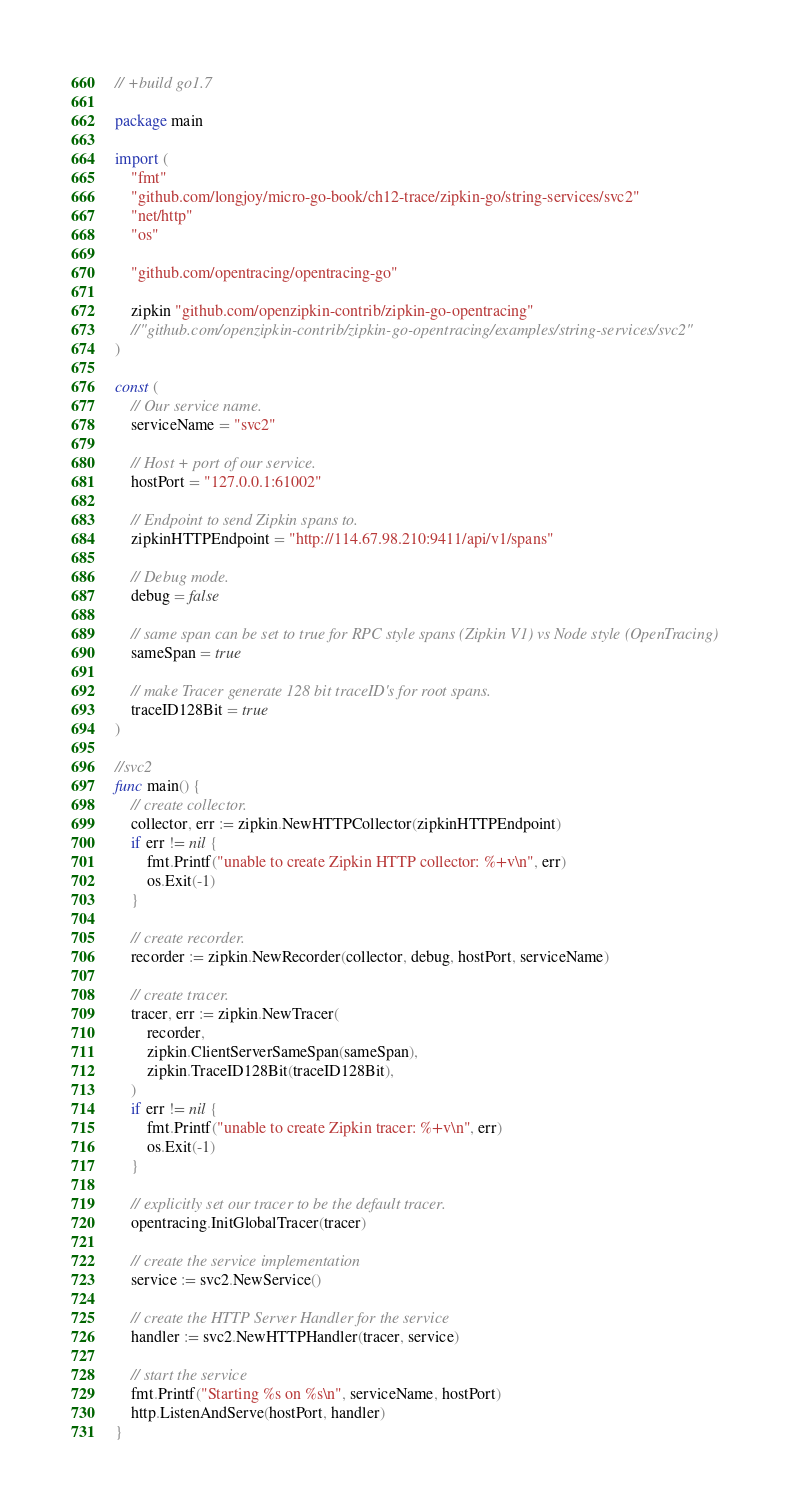Convert code to text. <code><loc_0><loc_0><loc_500><loc_500><_Go_>// +build go1.7

package main

import (
	"fmt"
	"github.com/longjoy/micro-go-book/ch12-trace/zipkin-go/string-services/svc2"
	"net/http"
	"os"

	"github.com/opentracing/opentracing-go"

	zipkin "github.com/openzipkin-contrib/zipkin-go-opentracing"
	//"github.com/openzipkin-contrib/zipkin-go-opentracing/examples/string-services/svc2"
)

const (
	// Our service name.
	serviceName = "svc2"

	// Host + port of our service.
	hostPort = "127.0.0.1:61002"

	// Endpoint to send Zipkin spans to.
	zipkinHTTPEndpoint = "http://114.67.98.210:9411/api/v1/spans"

	// Debug mode.
	debug = false

	// same span can be set to true for RPC style spans (Zipkin V1) vs Node style (OpenTracing)
	sameSpan = true

	// make Tracer generate 128 bit traceID's for root spans.
	traceID128Bit = true
)

//svc2
func main() {
	// create collector.
	collector, err := zipkin.NewHTTPCollector(zipkinHTTPEndpoint)
	if err != nil {
		fmt.Printf("unable to create Zipkin HTTP collector: %+v\n", err)
		os.Exit(-1)
	}

	// create recorder.
	recorder := zipkin.NewRecorder(collector, debug, hostPort, serviceName)

	// create tracer.
	tracer, err := zipkin.NewTracer(
		recorder,
		zipkin.ClientServerSameSpan(sameSpan),
		zipkin.TraceID128Bit(traceID128Bit),
	)
	if err != nil {
		fmt.Printf("unable to create Zipkin tracer: %+v\n", err)
		os.Exit(-1)
	}

	// explicitly set our tracer to be the default tracer.
	opentracing.InitGlobalTracer(tracer)

	// create the service implementation
	service := svc2.NewService()

	// create the HTTP Server Handler for the service
	handler := svc2.NewHTTPHandler(tracer, service)

	// start the service
	fmt.Printf("Starting %s on %s\n", serviceName, hostPort)
	http.ListenAndServe(hostPort, handler)
}
</code> 